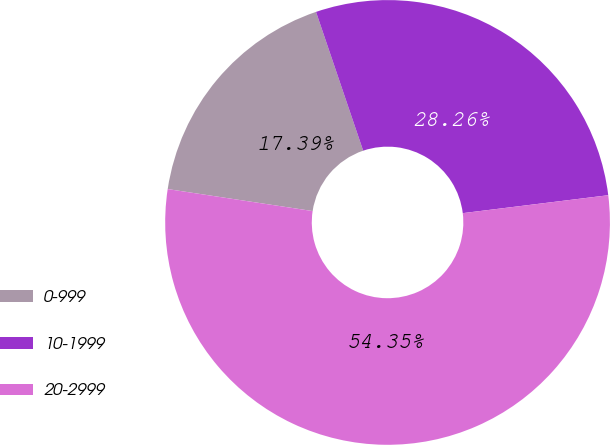<chart> <loc_0><loc_0><loc_500><loc_500><pie_chart><fcel>0-999<fcel>10-1999<fcel>20-2999<nl><fcel>17.39%<fcel>28.26%<fcel>54.35%<nl></chart> 